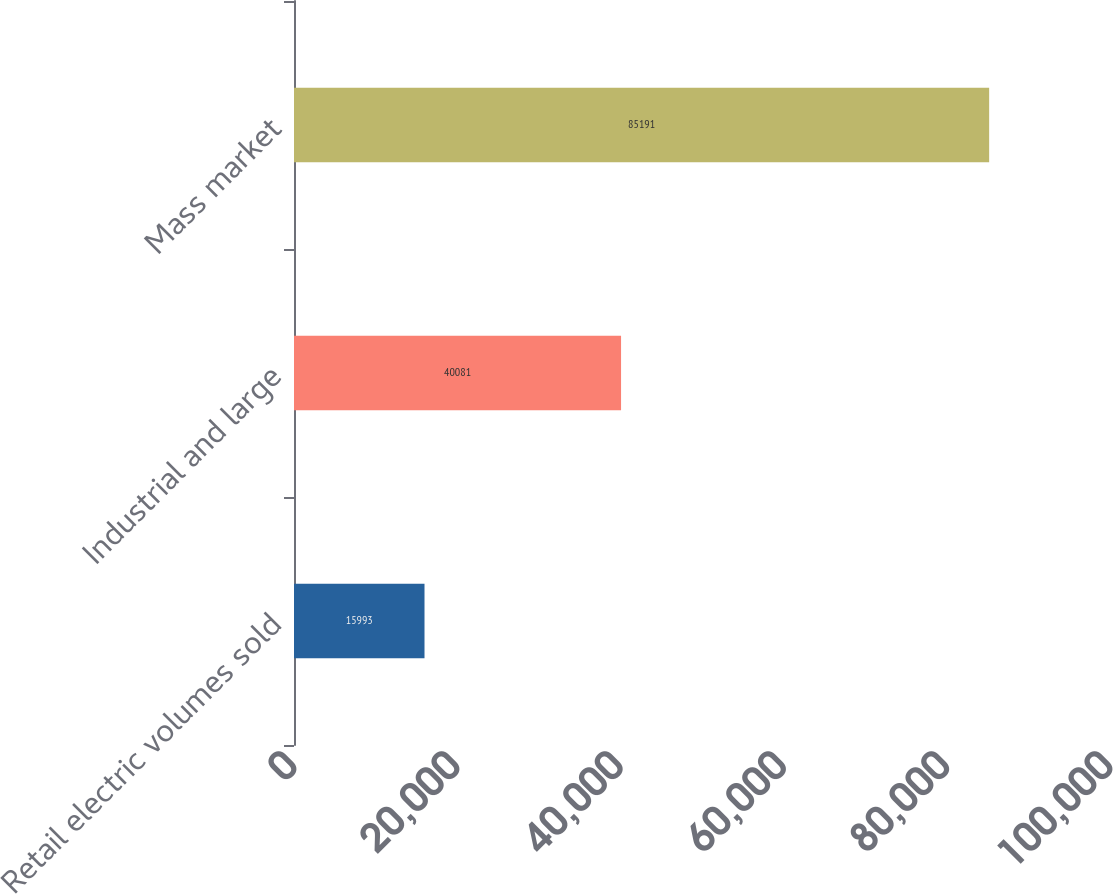Convert chart. <chart><loc_0><loc_0><loc_500><loc_500><bar_chart><fcel>Retail electric volumes sold<fcel>Industrial and large<fcel>Mass market<nl><fcel>15993<fcel>40081<fcel>85191<nl></chart> 